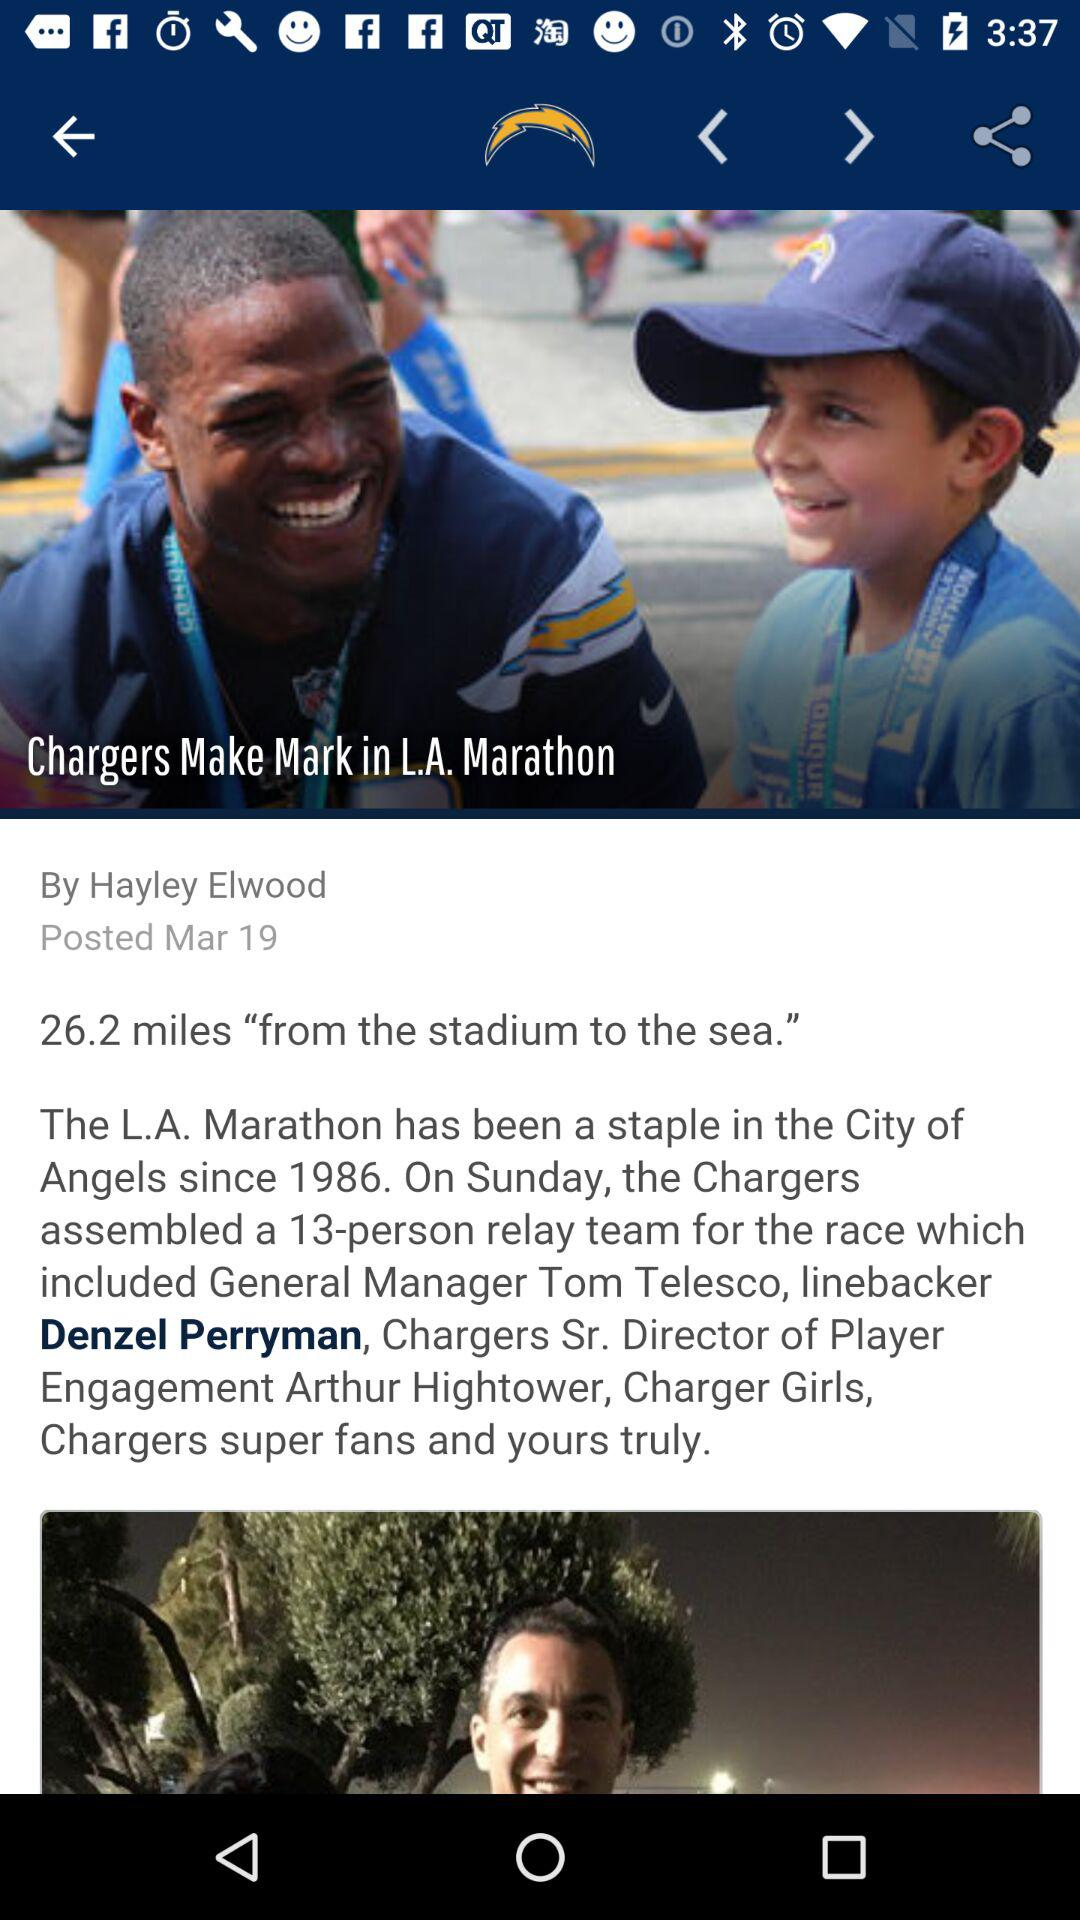What is the posted date? The posted date is March 19. 